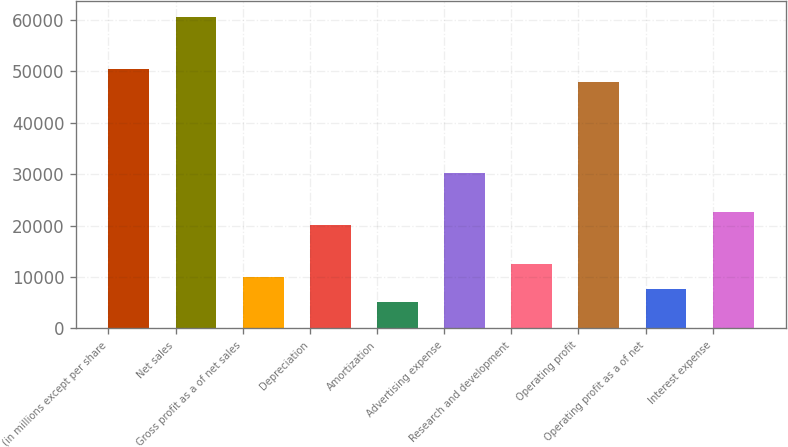Convert chart. <chart><loc_0><loc_0><loc_500><loc_500><bar_chart><fcel>(in millions except per share<fcel>Net sales<fcel>Gross profit as a of net sales<fcel>Depreciation<fcel>Amortization<fcel>Advertising expense<fcel>Research and development<fcel>Operating profit<fcel>Operating profit as a of net<fcel>Interest expense<nl><fcel>50499<fcel>60598.6<fcel>10100.6<fcel>20200.2<fcel>5050.81<fcel>30299.8<fcel>12625.5<fcel>47974.1<fcel>7575.71<fcel>22725.1<nl></chart> 